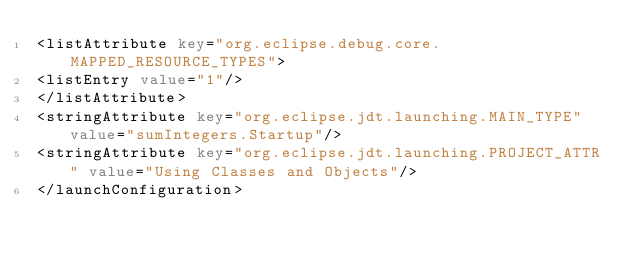<code> <loc_0><loc_0><loc_500><loc_500><_XML_><listAttribute key="org.eclipse.debug.core.MAPPED_RESOURCE_TYPES">
<listEntry value="1"/>
</listAttribute>
<stringAttribute key="org.eclipse.jdt.launching.MAIN_TYPE" value="sumIntegers.Startup"/>
<stringAttribute key="org.eclipse.jdt.launching.PROJECT_ATTR" value="Using Classes and Objects"/>
</launchConfiguration>
</code> 